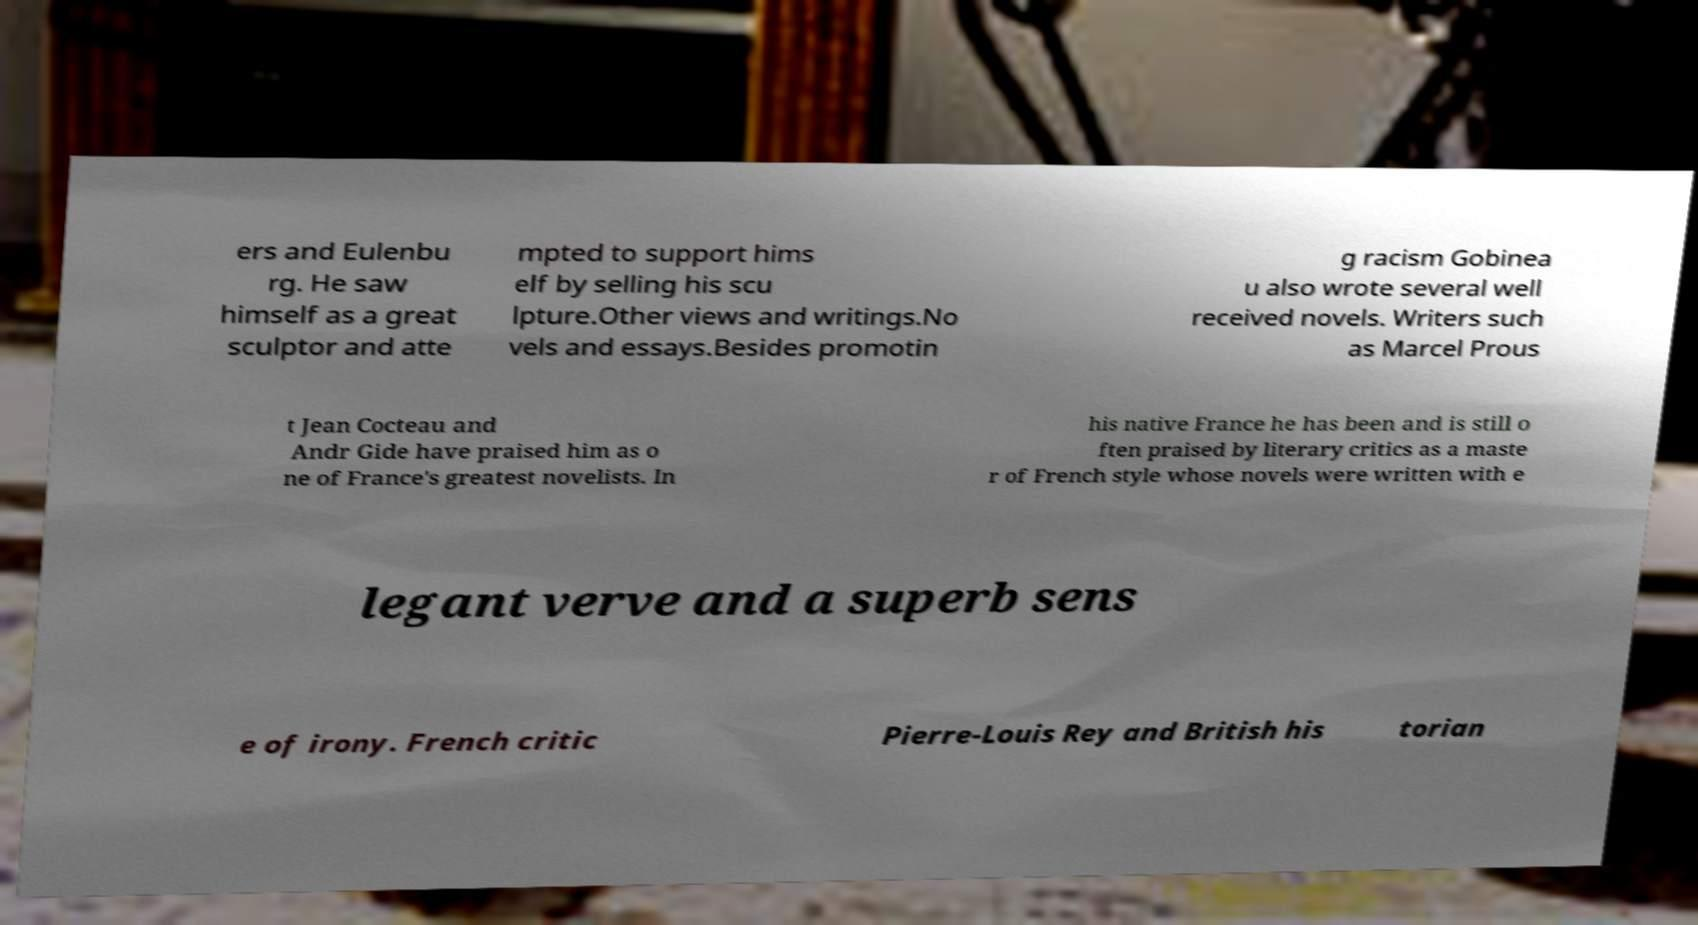There's text embedded in this image that I need extracted. Can you transcribe it verbatim? ers and Eulenbu rg. He saw himself as a great sculptor and atte mpted to support hims elf by selling his scu lpture.Other views and writings.No vels and essays.Besides promotin g racism Gobinea u also wrote several well received novels. Writers such as Marcel Prous t Jean Cocteau and Andr Gide have praised him as o ne of France's greatest novelists. In his native France he has been and is still o ften praised by literary critics as a maste r of French style whose novels were written with e legant verve and a superb sens e of irony. French critic Pierre-Louis Rey and British his torian 